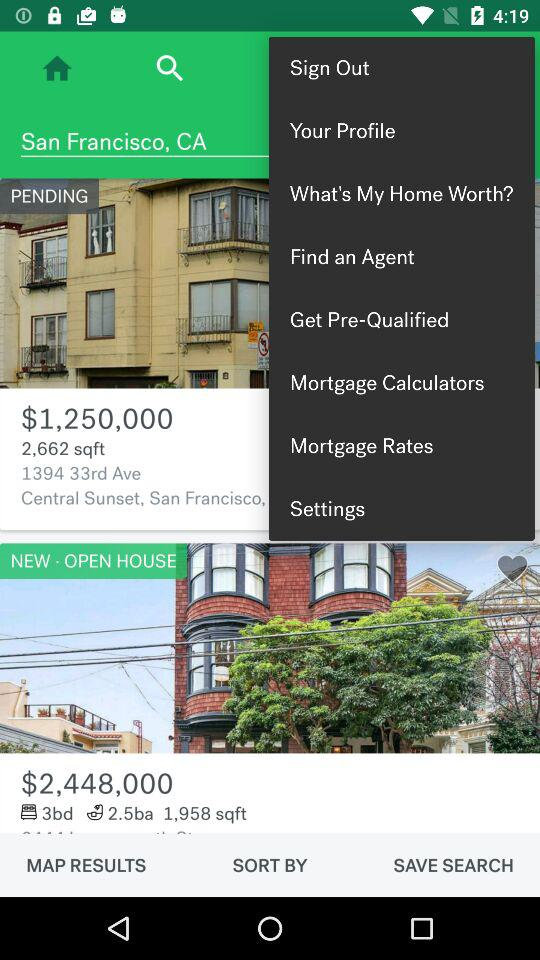What is the price of the new open house? The price of the new open house is $2,448,000. 